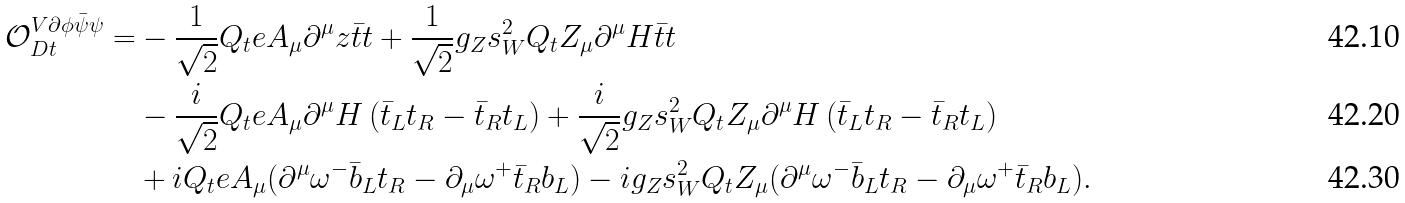Convert formula to latex. <formula><loc_0><loc_0><loc_500><loc_500>\mathcal { O } _ { D t } ^ { V \partial \phi \bar { \psi } \psi } = & - \frac { 1 } { \sqrt { 2 } } Q _ { t } e A _ { \mu } \partial ^ { \mu } z \bar { t } t + \frac { 1 } { \sqrt { 2 } } g _ { Z } s _ { W } ^ { 2 } Q _ { t } Z _ { \mu } \partial ^ { \mu } H \bar { t } t \\ & - \frac { i } { \sqrt { 2 } } Q _ { t } e A _ { \mu } \partial ^ { \mu } H \left ( \bar { t } _ { L } t _ { R } - \bar { t } _ { R } t _ { L } \right ) + \frac { i } { \sqrt { 2 } } g _ { Z } s _ { W } ^ { 2 } Q _ { t } Z _ { \mu } \partial ^ { \mu } H \left ( \bar { t } _ { L } t _ { R } - \bar { t } _ { R } t _ { L } \right ) \\ & + i Q _ { t } e A _ { \mu } ( \partial ^ { \mu } \omega ^ { - } \bar { b } _ { L } t _ { R } - \partial _ { \mu } \omega ^ { + } \bar { t } _ { R } b _ { L } ) - i g _ { Z } s _ { W } ^ { 2 } Q _ { t } Z _ { \mu } ( \partial ^ { \mu } \omega ^ { - } \bar { b } _ { L } t _ { R } - \partial _ { \mu } \omega ^ { + } \bar { t } _ { R } b _ { L } ) .</formula> 